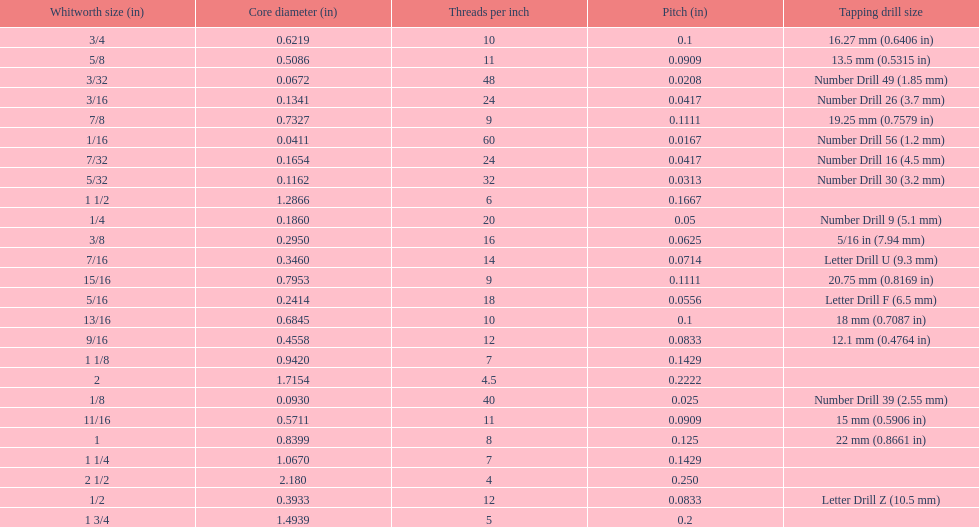What is the top amount of threads per inch? 60. 